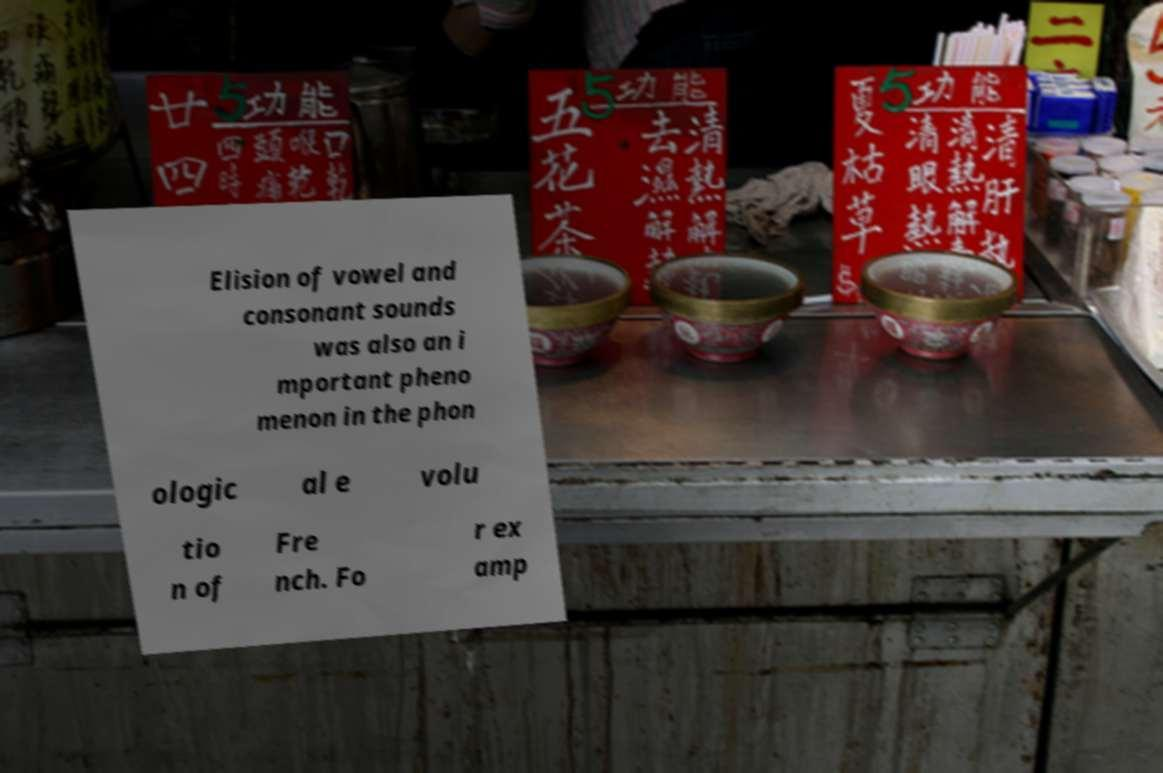Can you accurately transcribe the text from the provided image for me? Elision of vowel and consonant sounds was also an i mportant pheno menon in the phon ologic al e volu tio n of Fre nch. Fo r ex amp 